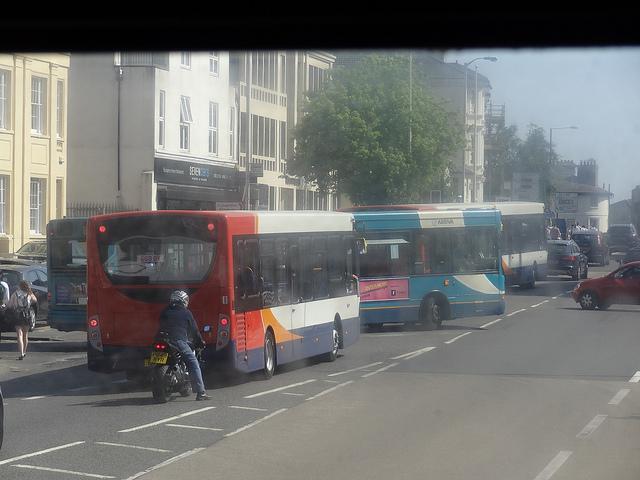How many buses are there?
Give a very brief answer. 3. How many buses are in the picture?
Give a very brief answer. 4. 